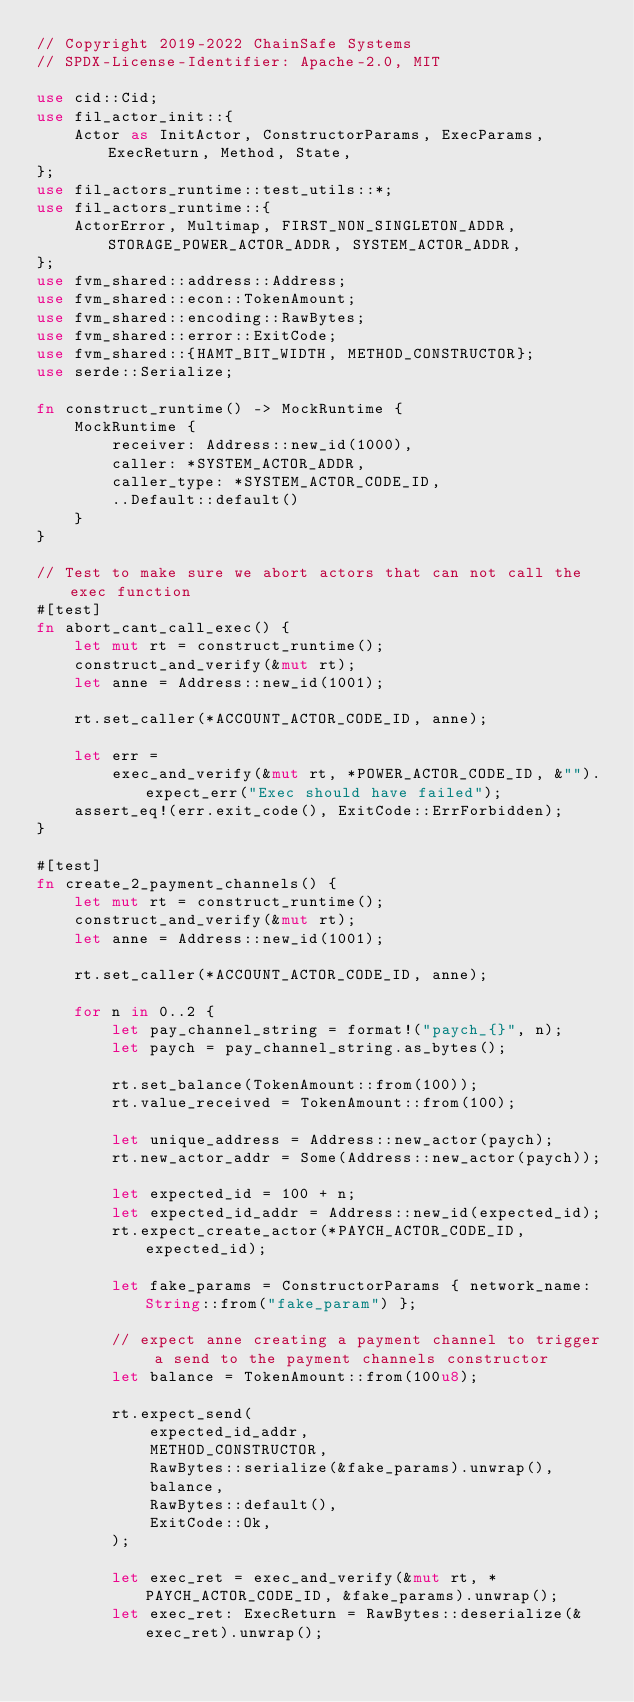Convert code to text. <code><loc_0><loc_0><loc_500><loc_500><_Rust_>// Copyright 2019-2022 ChainSafe Systems
// SPDX-License-Identifier: Apache-2.0, MIT

use cid::Cid;
use fil_actor_init::{
    Actor as InitActor, ConstructorParams, ExecParams, ExecReturn, Method, State,
};
use fil_actors_runtime::test_utils::*;
use fil_actors_runtime::{
    ActorError, Multimap, FIRST_NON_SINGLETON_ADDR, STORAGE_POWER_ACTOR_ADDR, SYSTEM_ACTOR_ADDR,
};
use fvm_shared::address::Address;
use fvm_shared::econ::TokenAmount;
use fvm_shared::encoding::RawBytes;
use fvm_shared::error::ExitCode;
use fvm_shared::{HAMT_BIT_WIDTH, METHOD_CONSTRUCTOR};
use serde::Serialize;

fn construct_runtime() -> MockRuntime {
    MockRuntime {
        receiver: Address::new_id(1000),
        caller: *SYSTEM_ACTOR_ADDR,
        caller_type: *SYSTEM_ACTOR_CODE_ID,
        ..Default::default()
    }
}

// Test to make sure we abort actors that can not call the exec function
#[test]
fn abort_cant_call_exec() {
    let mut rt = construct_runtime();
    construct_and_verify(&mut rt);
    let anne = Address::new_id(1001);

    rt.set_caller(*ACCOUNT_ACTOR_CODE_ID, anne);

    let err =
        exec_and_verify(&mut rt, *POWER_ACTOR_CODE_ID, &"").expect_err("Exec should have failed");
    assert_eq!(err.exit_code(), ExitCode::ErrForbidden);
}

#[test]
fn create_2_payment_channels() {
    let mut rt = construct_runtime();
    construct_and_verify(&mut rt);
    let anne = Address::new_id(1001);

    rt.set_caller(*ACCOUNT_ACTOR_CODE_ID, anne);

    for n in 0..2 {
        let pay_channel_string = format!("paych_{}", n);
        let paych = pay_channel_string.as_bytes();

        rt.set_balance(TokenAmount::from(100));
        rt.value_received = TokenAmount::from(100);

        let unique_address = Address::new_actor(paych);
        rt.new_actor_addr = Some(Address::new_actor(paych));

        let expected_id = 100 + n;
        let expected_id_addr = Address::new_id(expected_id);
        rt.expect_create_actor(*PAYCH_ACTOR_CODE_ID, expected_id);

        let fake_params = ConstructorParams { network_name: String::from("fake_param") };

        // expect anne creating a payment channel to trigger a send to the payment channels constructor
        let balance = TokenAmount::from(100u8);

        rt.expect_send(
            expected_id_addr,
            METHOD_CONSTRUCTOR,
            RawBytes::serialize(&fake_params).unwrap(),
            balance,
            RawBytes::default(),
            ExitCode::Ok,
        );

        let exec_ret = exec_and_verify(&mut rt, *PAYCH_ACTOR_CODE_ID, &fake_params).unwrap();
        let exec_ret: ExecReturn = RawBytes::deserialize(&exec_ret).unwrap();</code> 